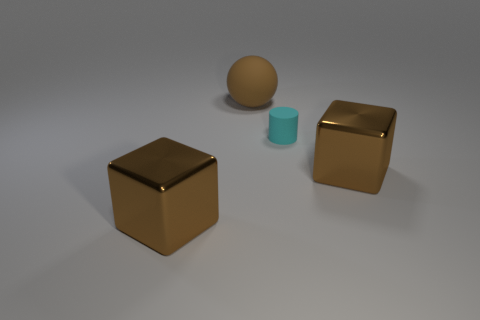How many brown blocks must be subtracted to get 1 brown blocks? 1 Add 3 large brown metallic blocks. How many objects exist? 7 Subtract all cylinders. How many objects are left? 3 Subtract all large brown rubber balls. Subtract all cyan matte cylinders. How many objects are left? 2 Add 1 big metallic cubes. How many big metallic cubes are left? 3 Add 4 large brown spheres. How many large brown spheres exist? 5 Subtract 0 green cylinders. How many objects are left? 4 